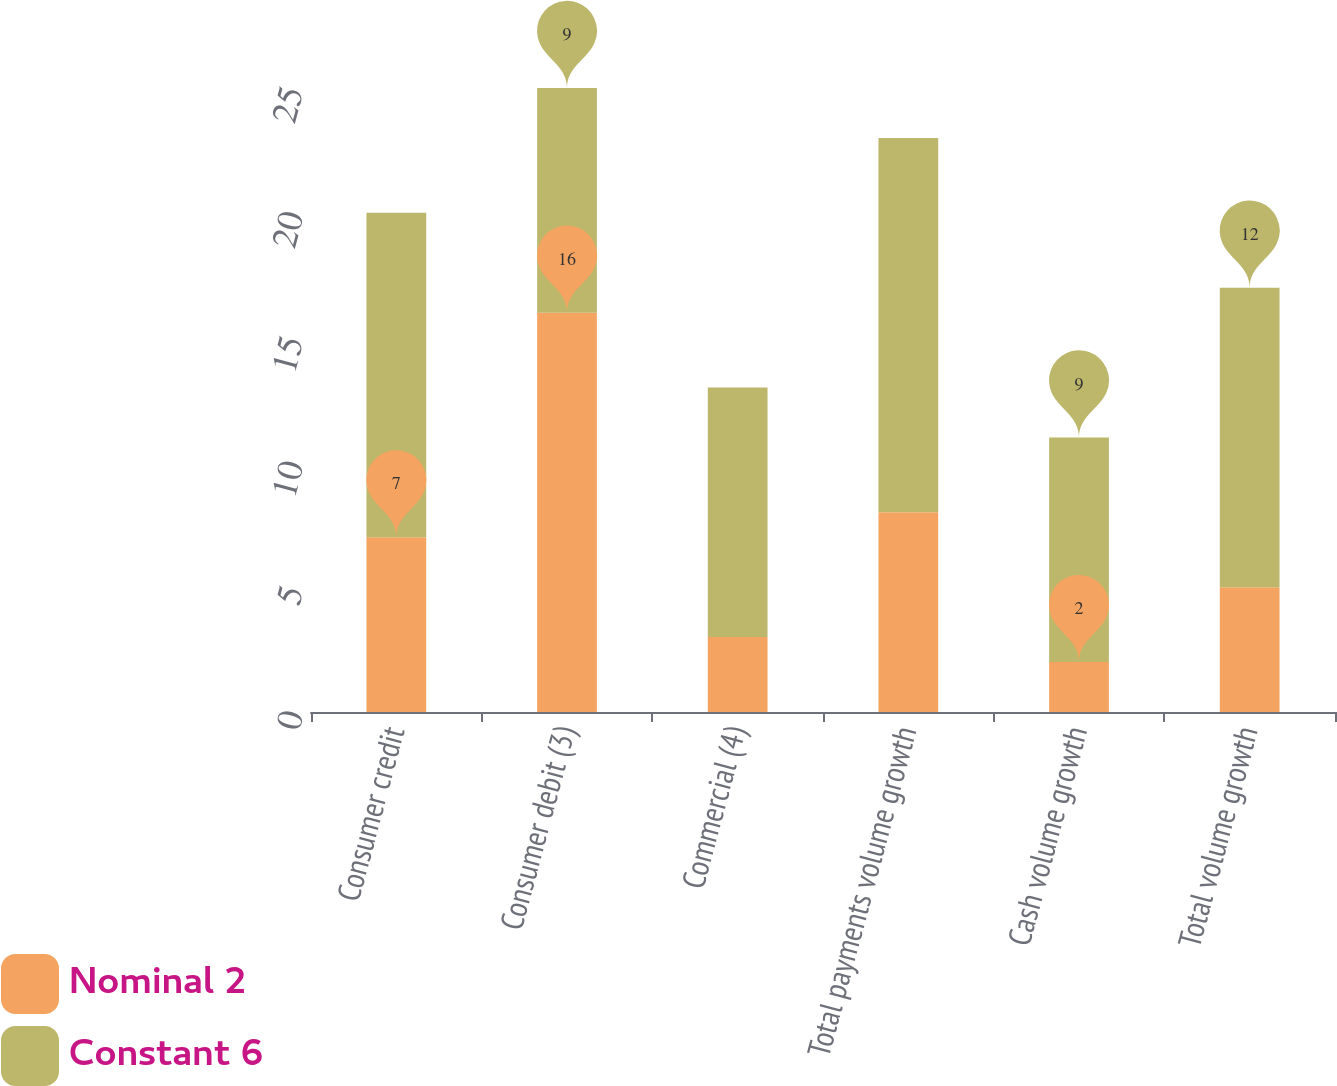Convert chart to OTSL. <chart><loc_0><loc_0><loc_500><loc_500><stacked_bar_chart><ecel><fcel>Consumer credit<fcel>Consumer debit (3)<fcel>Commercial (4)<fcel>Total payments volume growth<fcel>Cash volume growth<fcel>Total volume growth<nl><fcel>Nominal 2<fcel>7<fcel>16<fcel>3<fcel>8<fcel>2<fcel>5<nl><fcel>Constant 6<fcel>13<fcel>9<fcel>10<fcel>15<fcel>9<fcel>12<nl></chart> 